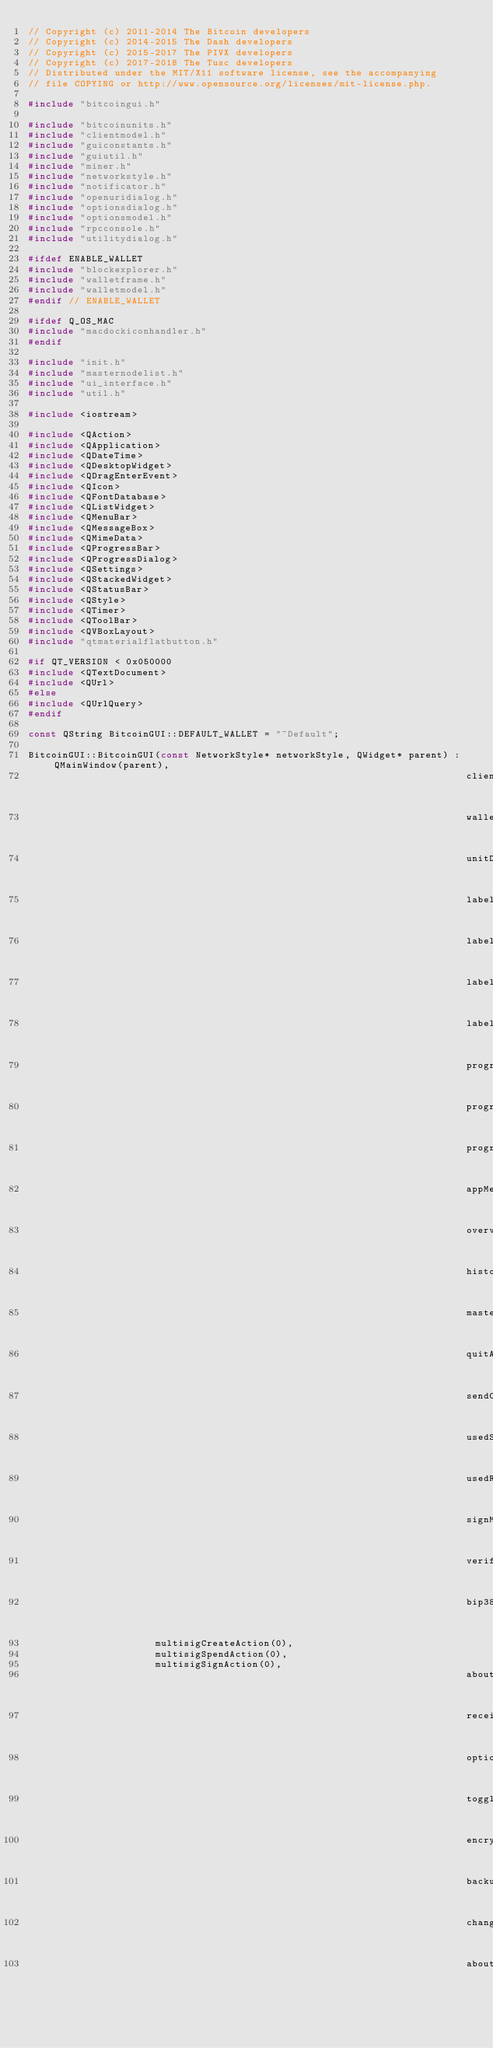Convert code to text. <code><loc_0><loc_0><loc_500><loc_500><_C++_>// Copyright (c) 2011-2014 The Bitcoin developers
// Copyright (c) 2014-2015 The Dash developers
// Copyright (c) 2015-2017 The PIVX developers
// Copyright (c) 2017-2018 The Tusc developers
// Distributed under the MIT/X11 software license, see the accompanying
// file COPYING or http://www.opensource.org/licenses/mit-license.php.

#include "bitcoingui.h"

#include "bitcoinunits.h"
#include "clientmodel.h"
#include "guiconstants.h"
#include "guiutil.h"
#include "miner.h"
#include "networkstyle.h"
#include "notificator.h"
#include "openuridialog.h"
#include "optionsdialog.h"
#include "optionsmodel.h"
#include "rpcconsole.h"
#include "utilitydialog.h"

#ifdef ENABLE_WALLET
#include "blockexplorer.h"
#include "walletframe.h"
#include "walletmodel.h"
#endif // ENABLE_WALLET

#ifdef Q_OS_MAC
#include "macdockiconhandler.h"
#endif

#include "init.h"
#include "masternodelist.h"
#include "ui_interface.h"
#include "util.h"

#include <iostream>

#include <QAction>
#include <QApplication>
#include <QDateTime>
#include <QDesktopWidget>
#include <QDragEnterEvent>
#include <QIcon>
#include <QFontDatabase>
#include <QListWidget>
#include <QMenuBar>
#include <QMessageBox>
#include <QMimeData>
#include <QProgressBar>
#include <QProgressDialog>
#include <QSettings>
#include <QStackedWidget>
#include <QStatusBar>
#include <QStyle>
#include <QTimer>
#include <QToolBar>
#include <QVBoxLayout>
#include "qtmaterialflatbutton.h"

#if QT_VERSION < 0x050000
#include <QTextDocument>
#include <QUrl>
#else
#include <QUrlQuery>
#endif

const QString BitcoinGUI::DEFAULT_WALLET = "~Default";

BitcoinGUI::BitcoinGUI(const NetworkStyle* networkStyle, QWidget* parent) : QMainWindow(parent),
                                                                            clientModel(0),
                                                                            walletFrame(0),
                                                                            unitDisplayControl(0),
                                                                            labelStakingIcon(0),
                                                                            labelEncryptionIcon(0),
                                                                            labelConnectionsIcon(0),
                                                                            labelBlocksIcon(0),
                                                                            progressBarLabel(0),
                                                                            progressBar(0),
                                                                            progressDialog(0),
                                                                            appMenuBar(0),
                                                                            overviewAction(0),
                                                                            historyAction(0),
                                                                            masternodeAction(0),
                                                                            quitAction(0),
                                                                            sendCoinsAction(0),
                                                                            usedSendingAddressesAction(0),
                                                                            usedReceivingAddressesAction(0),
                                                                            signMessageAction(0),
                                                                            verifyMessageAction(0),
                                                                            bip38ToolAction(0),
									    multisigCreateAction(0),
									    multisigSpendAction(0),
									    multisigSignAction(0),
                                                                            aboutAction(0),
                                                                            receiveCoinsAction(0),
                                                                            optionsAction(0),
                                                                            toggleHideAction(0),
                                                                            encryptWalletAction(0),
                                                                            backupWalletAction(0),
                                                                            changePassphraseAction(0),
                                                                            aboutQtAction(0),</code> 